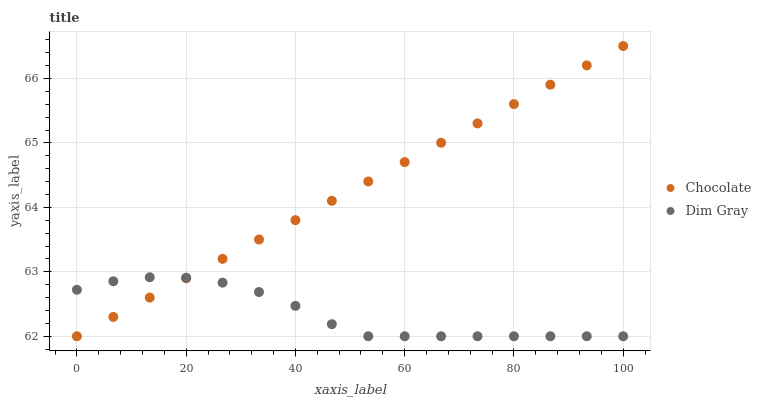Does Dim Gray have the minimum area under the curve?
Answer yes or no. Yes. Does Chocolate have the maximum area under the curve?
Answer yes or no. Yes. Does Chocolate have the minimum area under the curve?
Answer yes or no. No. Is Chocolate the smoothest?
Answer yes or no. Yes. Is Dim Gray the roughest?
Answer yes or no. Yes. Is Chocolate the roughest?
Answer yes or no. No. Does Dim Gray have the lowest value?
Answer yes or no. Yes. Does Chocolate have the highest value?
Answer yes or no. Yes. Does Chocolate intersect Dim Gray?
Answer yes or no. Yes. Is Chocolate less than Dim Gray?
Answer yes or no. No. Is Chocolate greater than Dim Gray?
Answer yes or no. No. 